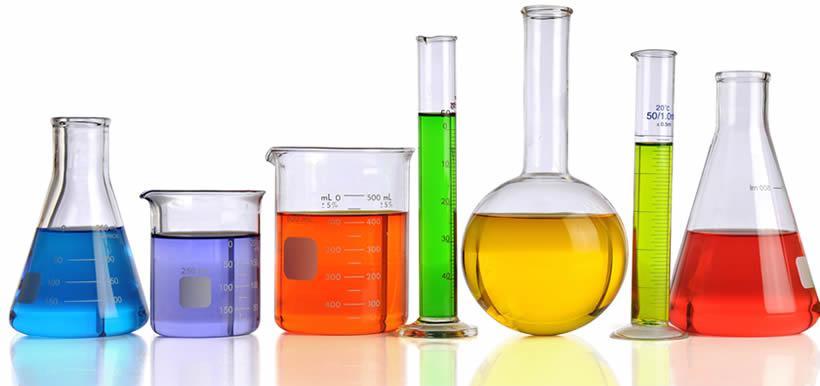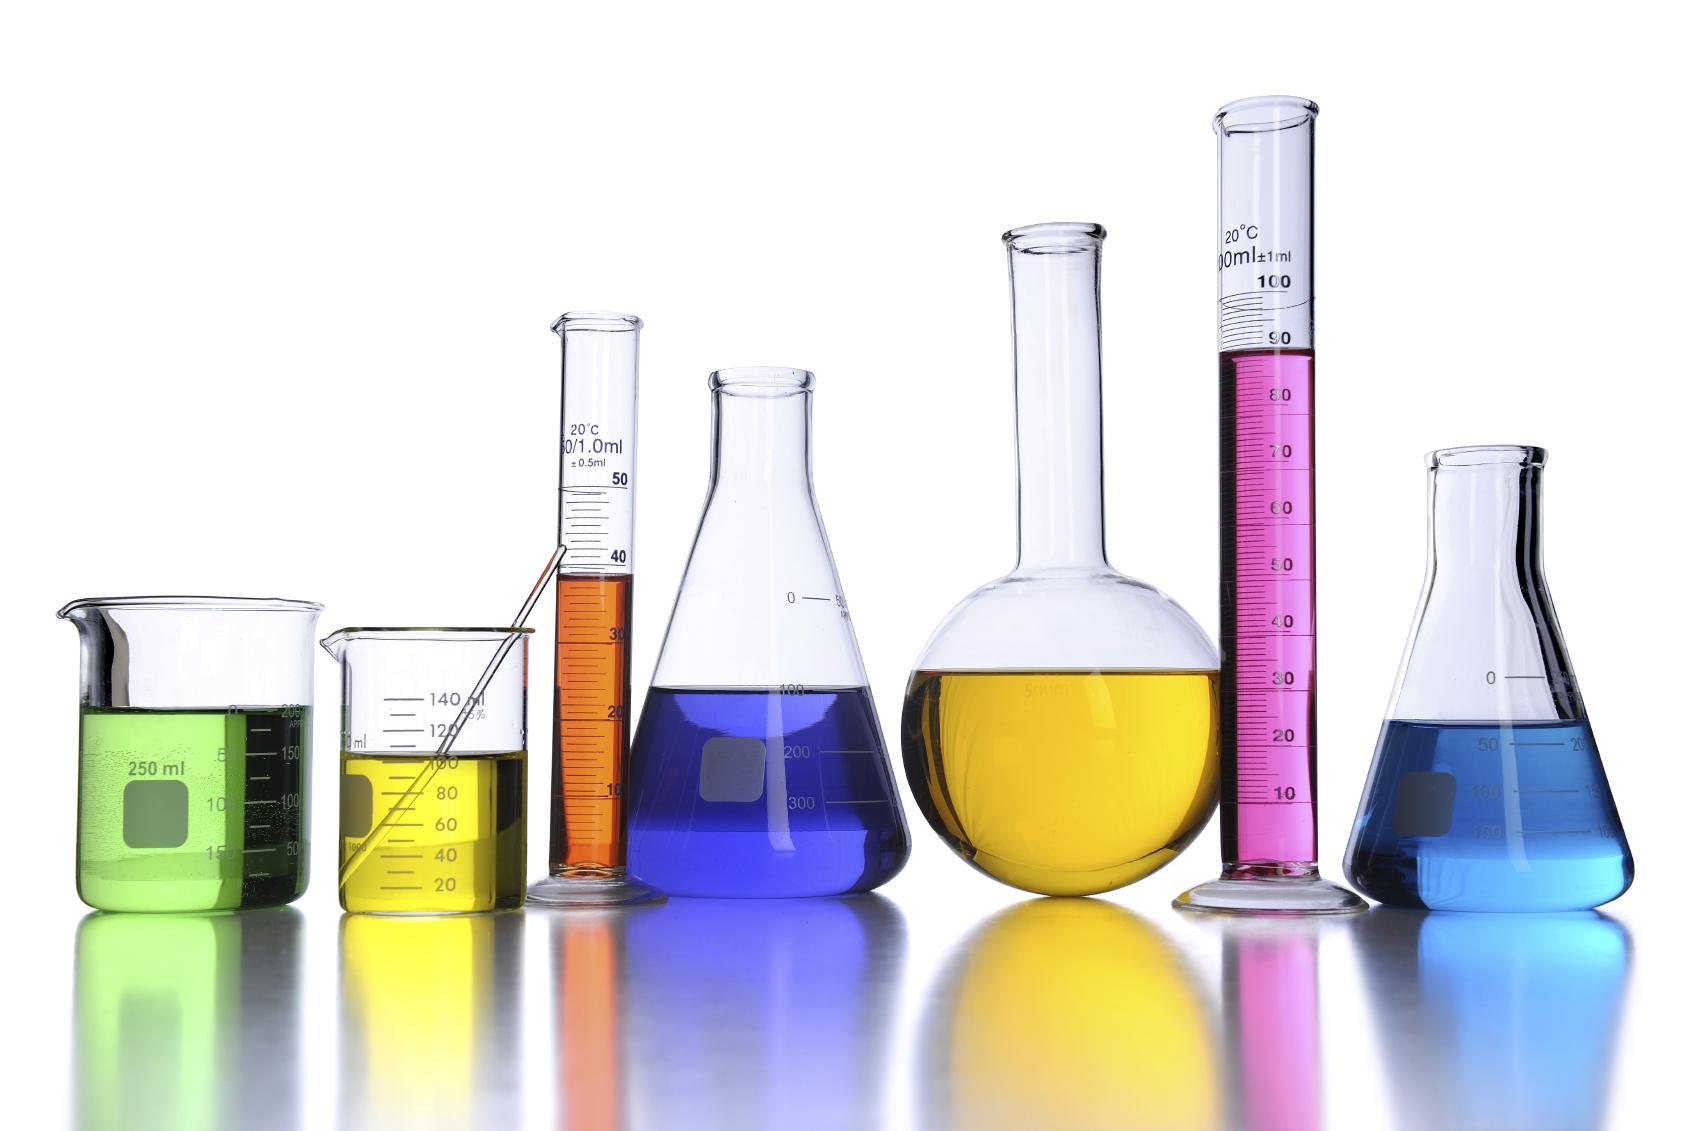The first image is the image on the left, the second image is the image on the right. Given the left and right images, does the statement "All the containers have liquid in them." hold true? Answer yes or no. Yes. The first image is the image on the left, the second image is the image on the right. Examine the images to the left and right. Is the description "In the image to the right, one of the flasks holds a yellow liquid." accurate? Answer yes or no. Yes. 